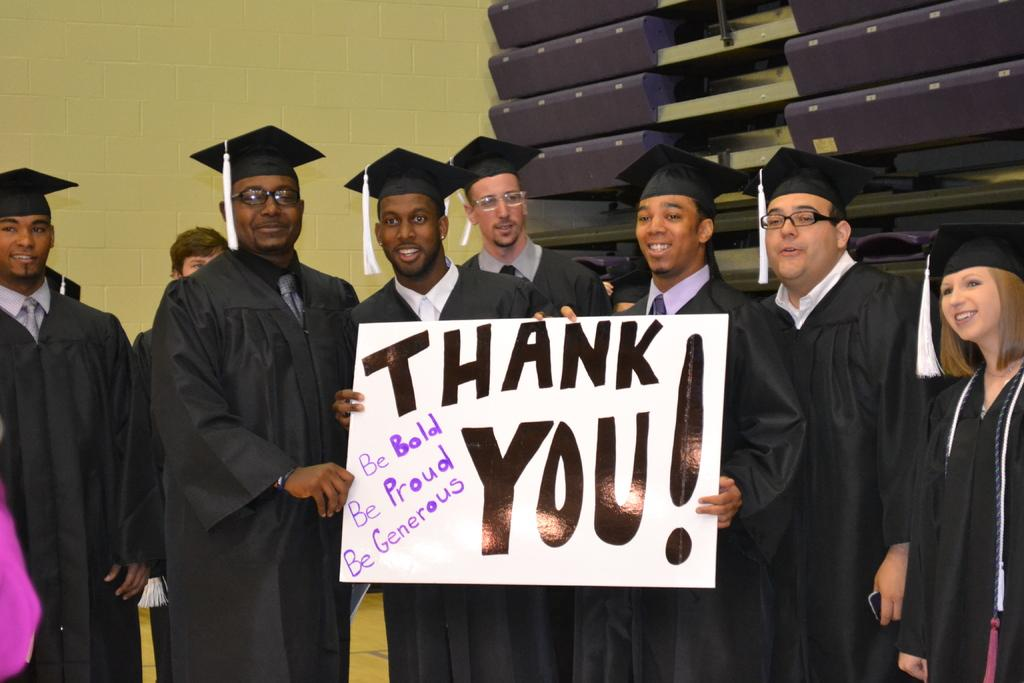Who or what is present in the image? There are people in the image. How are the people positioned in the image? The people are standing in series in the center of the image. What are the people holding in the image? The people are holding a poster. What message is on the poster? The poster has the words "thank you" written on it. What type of liquid can be seen flowing from the poster in the image? There is no liquid flowing from the poster in the image; it only has the words "thank you" written on it. 